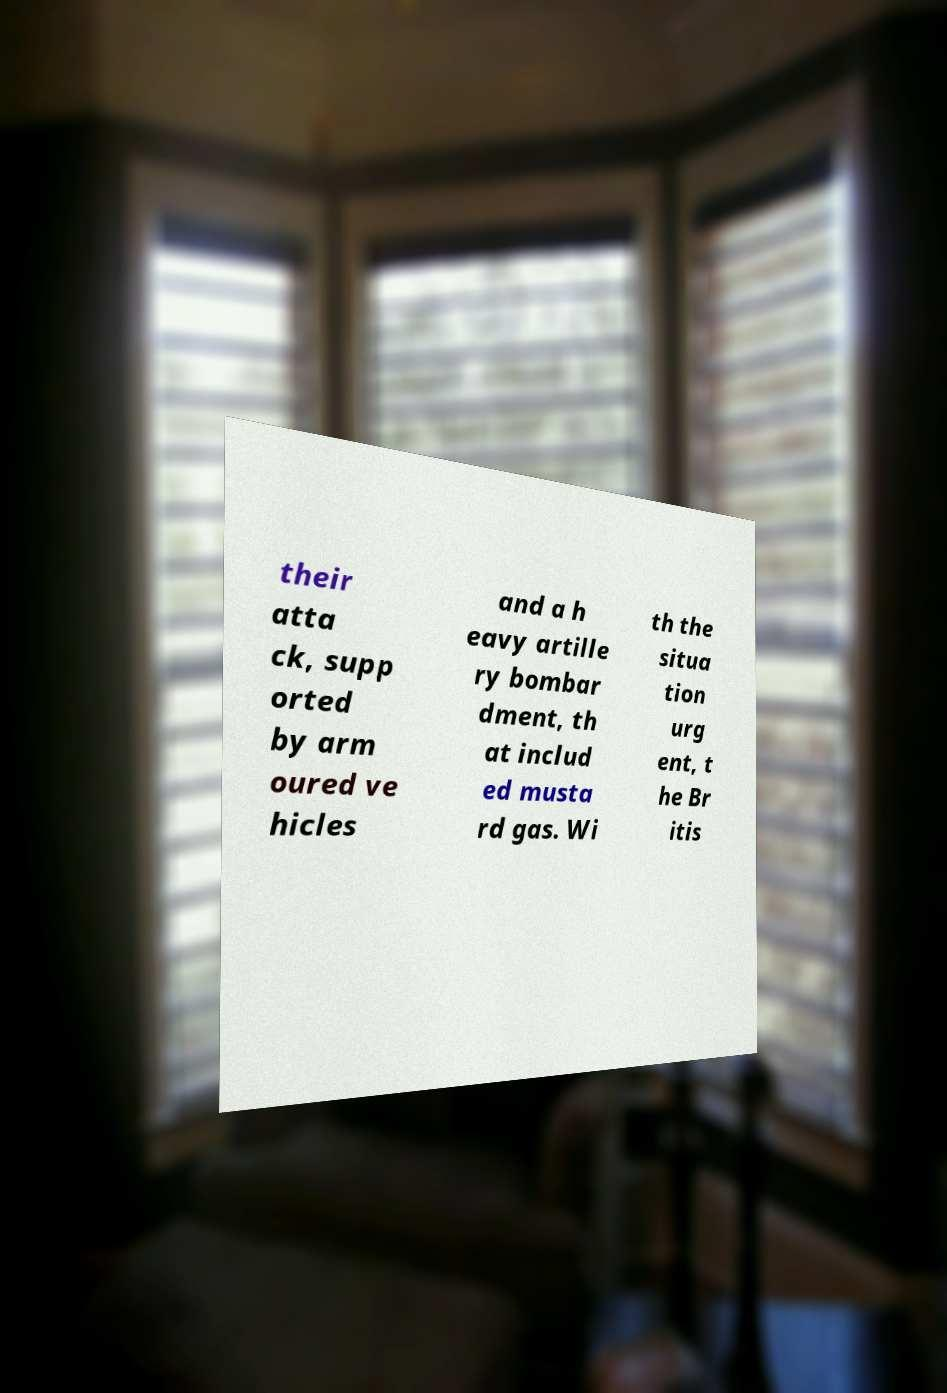I need the written content from this picture converted into text. Can you do that? their atta ck, supp orted by arm oured ve hicles and a h eavy artille ry bombar dment, th at includ ed musta rd gas. Wi th the situa tion urg ent, t he Br itis 